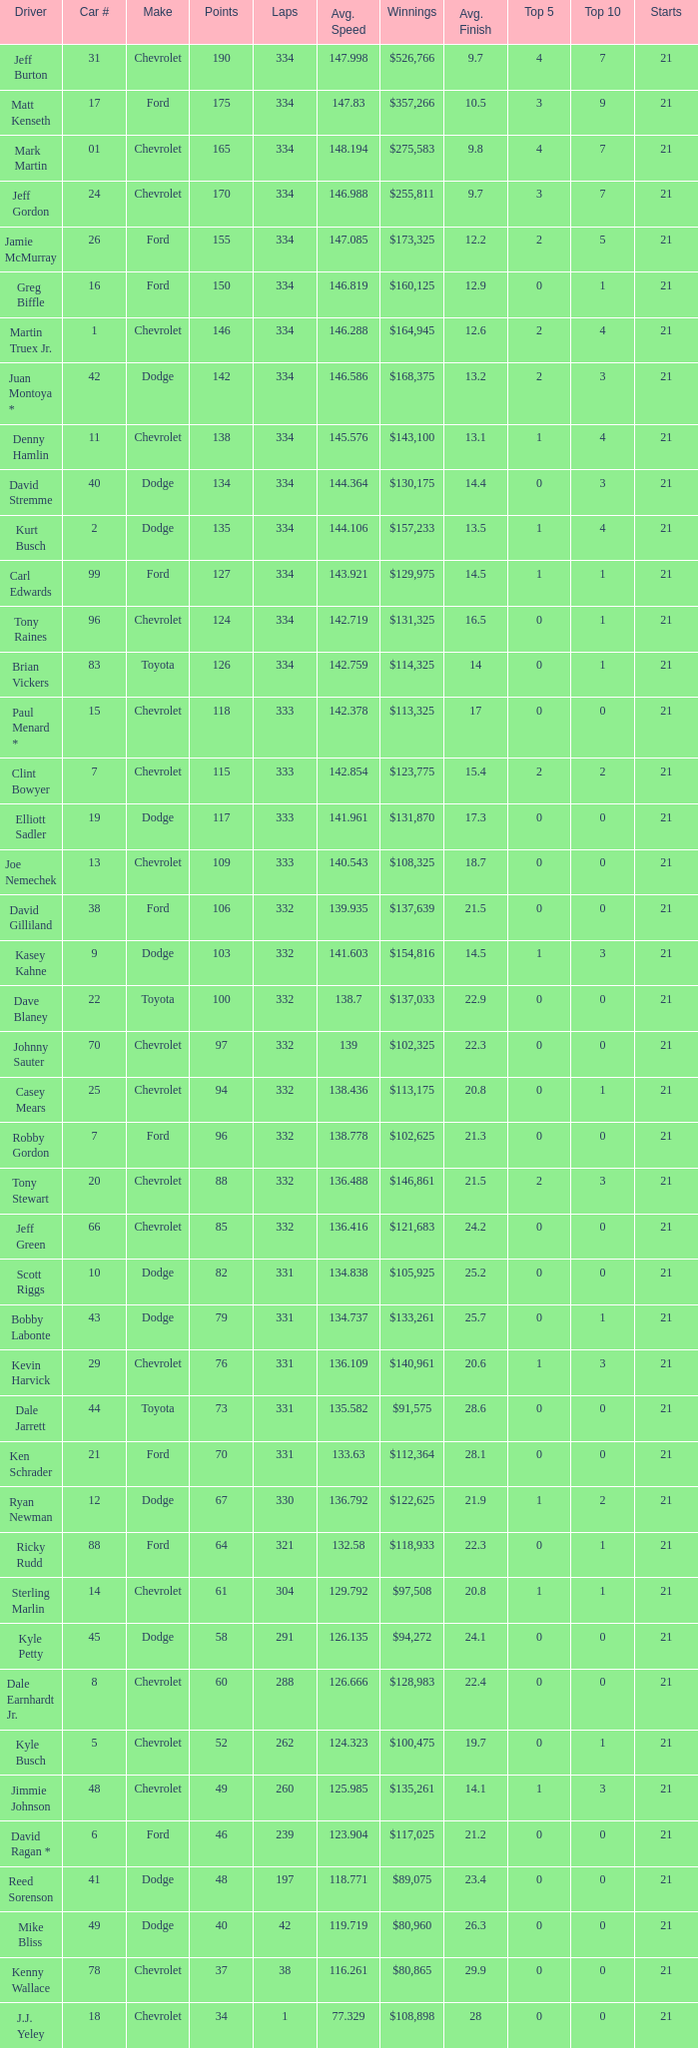How many total laps did the Chevrolet that won $97,508 make? 1.0. 